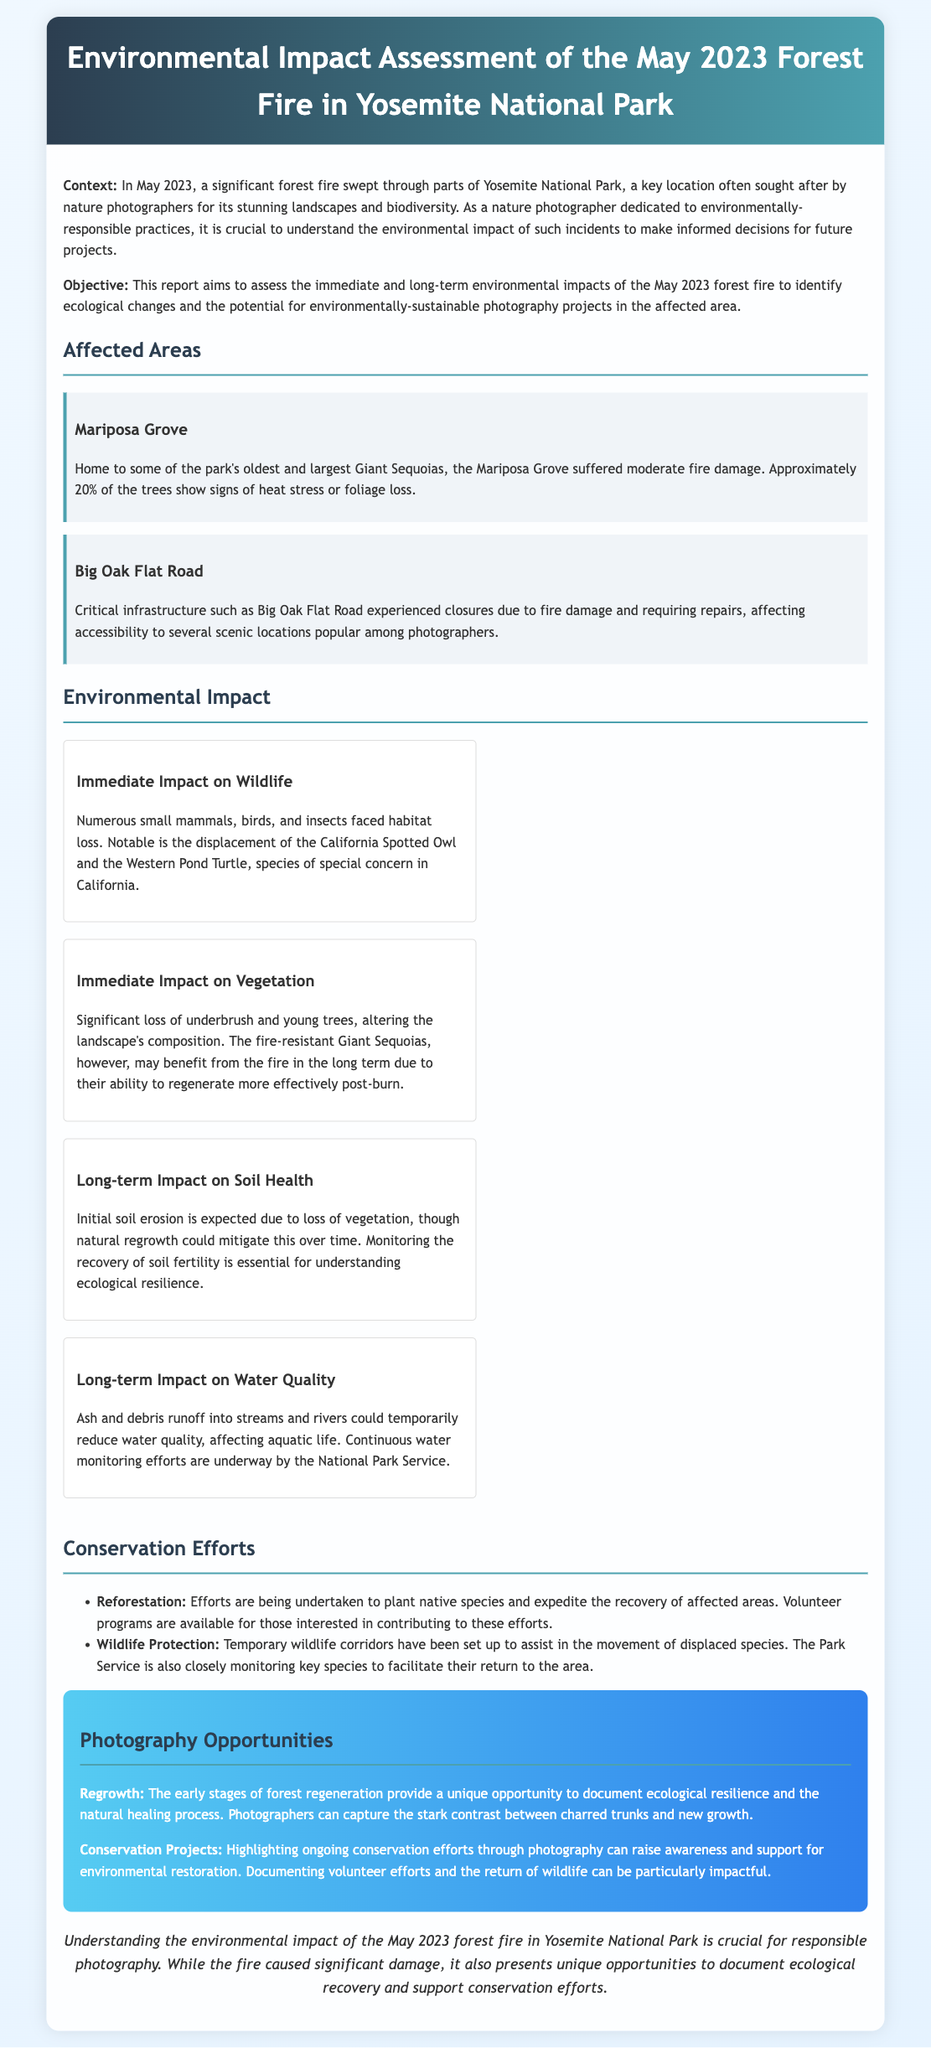what month did the forest fire occur? The document states that the forest fire in Yosemite National Park occurred in May 2023.
Answer: May 2023 what percentage of trees in Mariposa Grove show signs of heat stress? The document indicates that approximately 20% of the trees in Mariposa Grove show signs of heat stress or foliage loss.
Answer: 20% which two species were noted as facing habitat loss? The document mentions the California Spotted Owl and the Western Pond Turtle as species facing habitat loss.
Answer: California Spotted Owl and Western Pond Turtle what are the two main conservation efforts mentioned? The document details reforestation and wildlife protection as the two main conservation efforts underway.
Answer: Reforestation and wildlife protection what benefit may Giant Sequoias experience in the long term? The document explains that fire-resistant Giant Sequoias may benefit from the fire in the long term due to their ability to regenerate more effectively post-burn.
Answer: Regenerate more effectively how many wildlife corridors have been set up? The document describes that temporary wildlife corridors have been established for the movement of displaced species, but it does not specify a number.
Answer: Temporary wildlife corridors what photographic opportunity is highlighted regarding regrowth? The document states that the early stages of forest regeneration provide a unique opportunity to document ecological resilience.
Answer: Document ecological resilience what impact does ash runoff have on water quality? The document mentions that ash and debris runoff could temporarily reduce water quality, affecting aquatic life.
Answer: Temporarily reduce water quality 